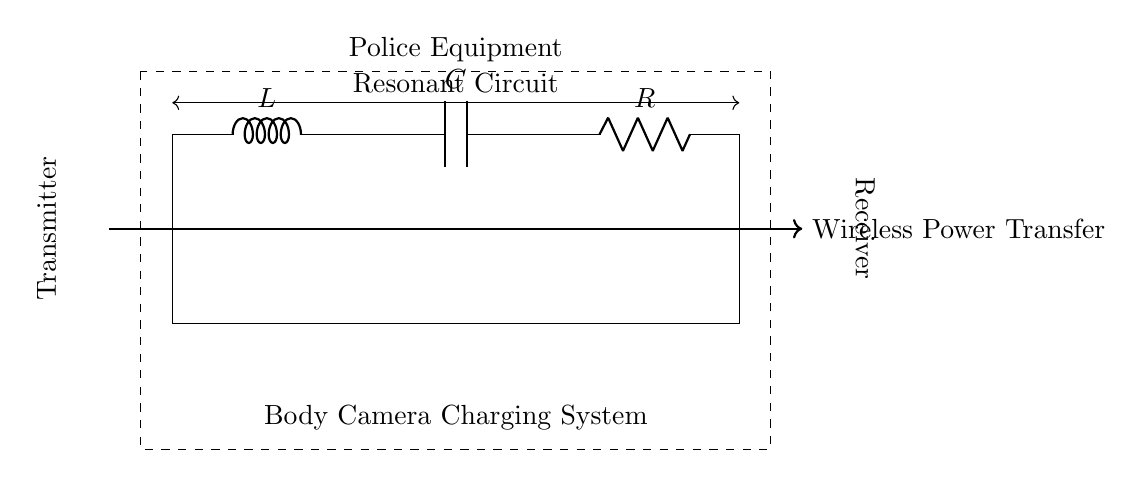What components are present in this circuit? The circuit contains an inductor, a capacitor, and a resistor, which are labeled as L, C, and R, respectively.
Answer: Inductor, Capacitor, Resistor What is the purpose of this circuit? The diagram indicates that the circuit is designed for wireless power transfer, specifically for a body camera charging system.
Answer: Wireless power transfer What is the role of the inductor in this circuit? The inductor stores energy in the magnetic field when current flows through it, which is crucial for resonant circuits to oscillate at a specific frequency.
Answer: Energy storage What is connected to the transmitter side of the circuit? The transmitter side of the circuit connects to the circuit components and is where the power is sent from, typically a power source.
Answer: Transmitter How does this resonant circuit enhance wireless charging efficiency? The resonant circuit achieves high efficiency by matching the load impedance to the source at the resonant frequency, allowing maximum power transfer.
Answer: Maximum power transfer What effect does changing the capacitance have on the resonant frequency? Increasing capacitance lowers the resonant frequency, while decreasing it raises the resonant frequency, following the formula that defines resonance.
Answer: Changes frequency What indicates that this circuit is a resonant circuit? The labeling of the circuit as a "Resonant Circuit" suggests that its design and components are geared towards resonance behavior, characterized by energy oscillation between the inductor and the capacitor.
Answer: Resonant Circuit label 